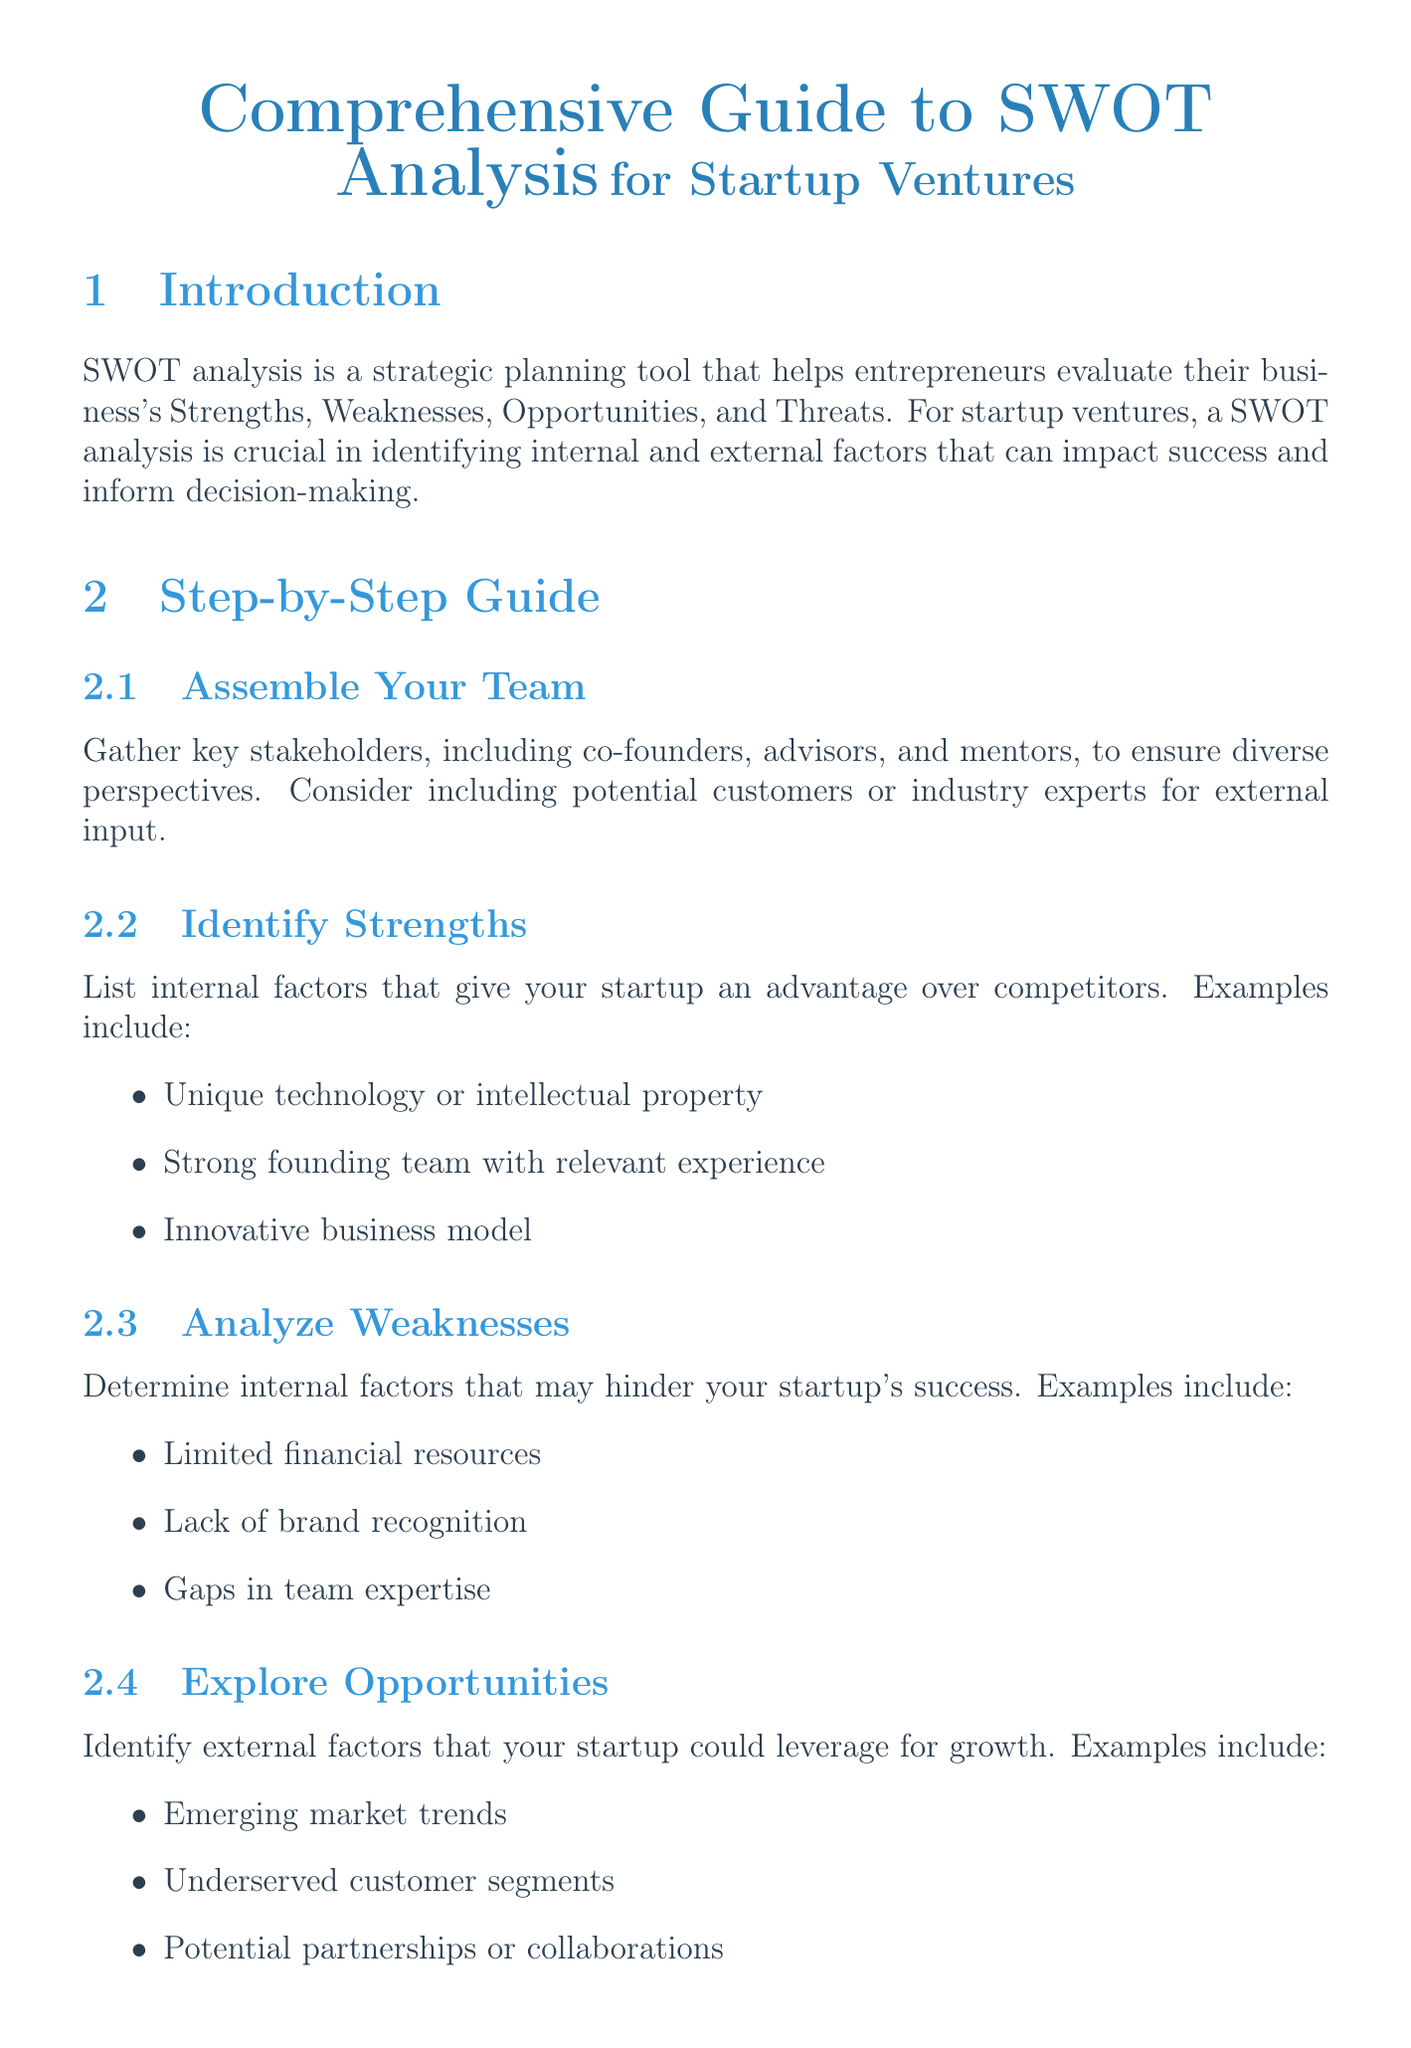What is a SWOT analysis? A SWOT analysis is a strategic planning tool that helps entrepreneurs evaluate their business's Strengths, Weaknesses, Opportunities, and Threats.
Answer: A strategic planning tool What should be included in the "Identify Strengths" step? This step involves listing internal factors that give your startup an advantage over competitors, such as unique technology and strong founding team.
Answer: Internal factors What are the common pitfalls in conducting a SWOT analysis? The document lists five common pitfalls, including overlooking critical weaknesses or threats and failing to prioritize findings.
Answer: Five common pitfalls What company is featured in the case study for the travel and hospitality industry? The document provides an example of Airbnb in the travel and hospitality industry.
Answer: Airbnb What is one action plan example related to limited financial resources? An action plan for limited financial resources could be to seek angel investors or apply for startup accelerators.
Answer: Seek angel investors What does the document suggest to improve the SWOT analysis process? The document suggests reviewing and updating your SWOT analysis regularly for improvement.
Answer: Review regularly What industry does Beyond Meat operate in? Beyond Meat is featured in the food technology industry according to the case study.
Answer: Food Technology How should items in the SWOT analysis be ranked? The items should be ranked based on their potential impact on your startup using a scoring system.
Answer: Scoring system 